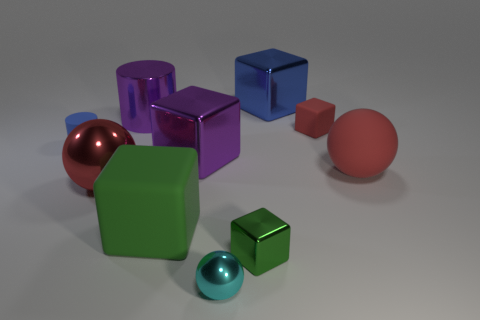Subtract all red cubes. How many cubes are left? 4 Subtract all tiny metal blocks. How many blocks are left? 4 Subtract all brown cubes. Subtract all purple spheres. How many cubes are left? 5 Subtract all spheres. How many objects are left? 7 Add 4 rubber spheres. How many rubber spheres exist? 5 Subtract 2 green blocks. How many objects are left? 8 Subtract all small gray matte cubes. Subtract all small matte cylinders. How many objects are left? 9 Add 6 cyan shiny balls. How many cyan shiny balls are left? 7 